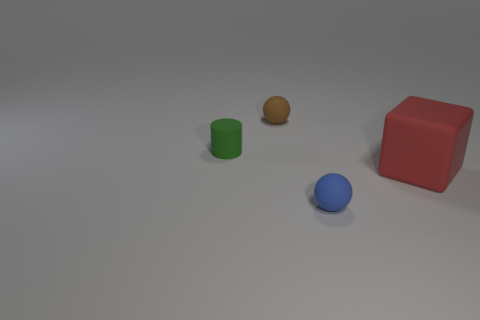Add 3 green matte objects. How many objects exist? 7 Subtract all cubes. How many objects are left? 3 Subtract 0 cyan blocks. How many objects are left? 4 Subtract all brown matte objects. Subtract all big red objects. How many objects are left? 2 Add 3 big red things. How many big red things are left? 4 Add 1 green rubber things. How many green rubber things exist? 2 